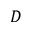Convert formula to latex. <formula><loc_0><loc_0><loc_500><loc_500>D</formula> 